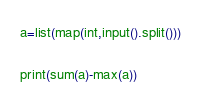Convert code to text. <code><loc_0><loc_0><loc_500><loc_500><_Python_>a=list(map(int,input().split()))

print(sum(a)-max(a))
</code> 